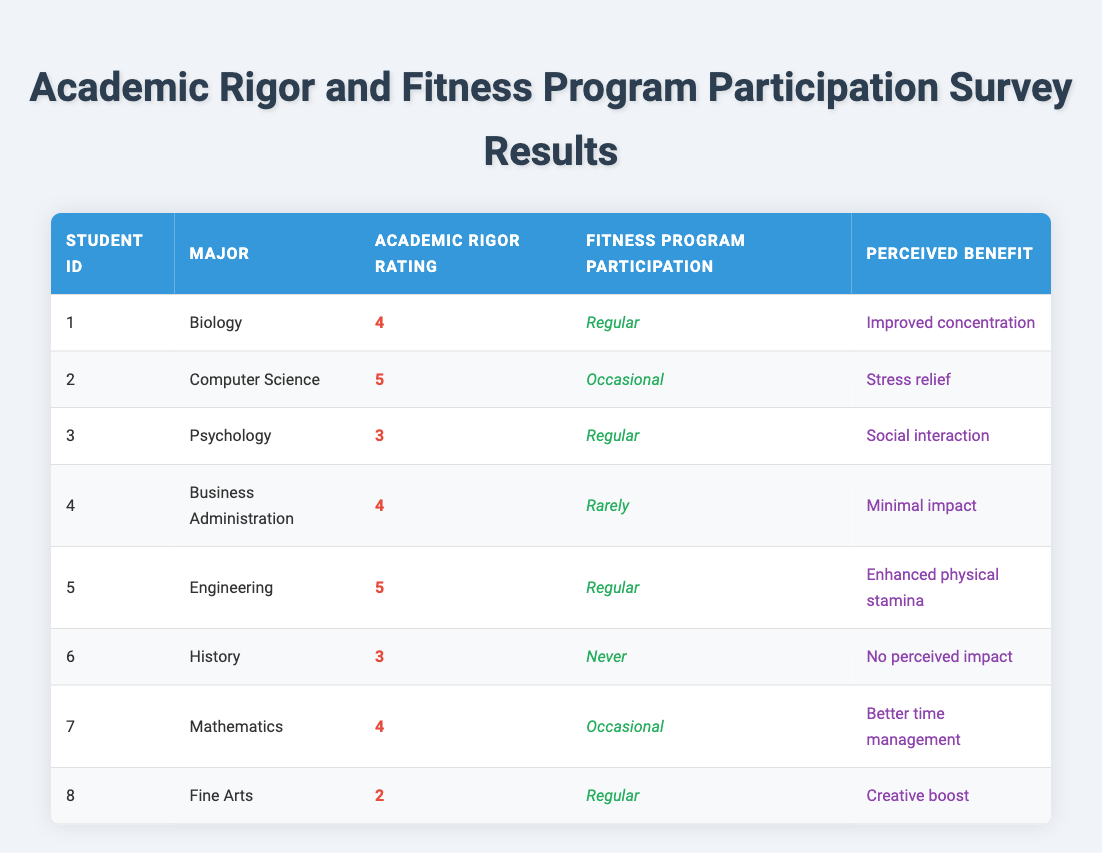What is the academic rigor rating of the student majoring in Biology? The table indicates that the student with a major in Biology has an academic rigor rating of 4. This is directly stated in the respective row for that student.
Answer: 4 How many students participated in the fitness program regularly? By examining the fitness program participation column, we can identify the students. The students with "Regular" participation are student IDs 1, 3, 5, and 8, totaling 4 students.
Answer: 4 What is the perceived benefit of fitness program participation for the Engineering major? The Engineering major's perceived benefit from fitness program participation is listed as "Enhanced physical stamina" in the corresponding row for that student.
Answer: Enhanced physical stamina Is it true that all students who rated academic rigor as 5 participate in the fitness program regularly? No, only the student with a major in Engineering who rated academic rigor as 5 participates regularly. The Computer Science student rated academic rigor as 5 and participates occasionally, proving the statement false.
Answer: No What is the average academic rigor rating of students who participate in fitness programs regularly? The academic rigor ratings for students participating regularly are 4 (Biology), 3 (Psychology), 5 (Engineering), and 2 (Fine Arts). The total is 14, and dividing by 4 (the number of students) gives an average of 3.5.
Answer: 3.5 How many students perceived their fitness program participation to have no benefits? From the data, only the History major has a perceived benefit of "No perceived impact," indicating that a total of 1 student feels this way.
Answer: 1 Which major had the highest academic rigor rating, and what was the perceived benefit for that student? The highest academic rigor rating of 5 was from the Engineering major, who perceived the benefit of "Enhanced physical stamina." This information can be confirmed by checking the relevant row in the table.
Answer: Engineering, Enhanced physical stamina Among students who participated occasionally in fitness programs, what is the most common perceived benefit? The Computer Science major perceives a benefit of "Stress relief," while the Mathematics major lists "Better time management." Neither benefit is repeated among these two students, so there is no common perceived benefit.
Answer: None How does the perceived benefit of fitness program participation differ between students who participate regularly and those who participate rarely? Students participating regularly perceive benefits such as "Improved concentration," "Social interaction," "Enhanced physical stamina," and "Creative boost." In contrast, the only rare participant perceived minimal impact. This shows that regular participants generally view fitness as more beneficial.
Answer: Regular participants perceive greater benefits than rare participants 